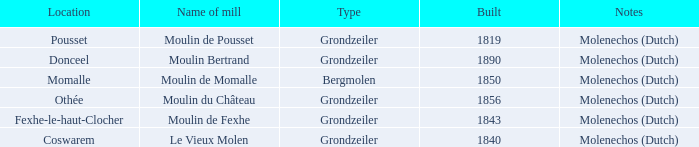What is year Built of the Moulin de Momalle Mill? 1850.0. 